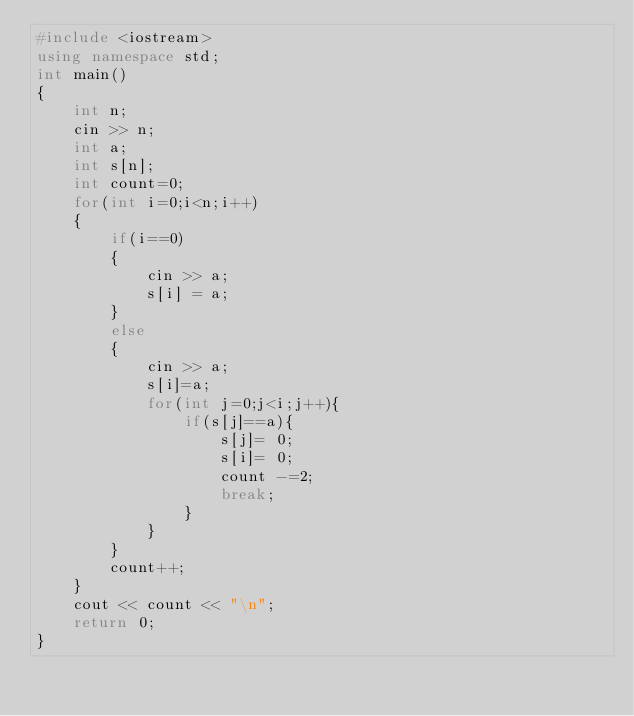<code> <loc_0><loc_0><loc_500><loc_500><_C++_>#include <iostream>
using namespace std;
int main()
{
    int n;
    cin >> n;
    int a;
    int s[n];
    int count=0;
    for(int i=0;i<n;i++)
    {
        if(i==0)
        {
            cin >> a;
            s[i] = a;
        }
        else
        {
            cin >> a;
            s[i]=a;
            for(int j=0;j<i;j++){
                if(s[j]==a){
                    s[j]= 0;
                    s[i]= 0;
                    count -=2;
                    break;
                }
            }
        }
        count++;    
    }
    cout << count << "\n";
    return 0;
}</code> 